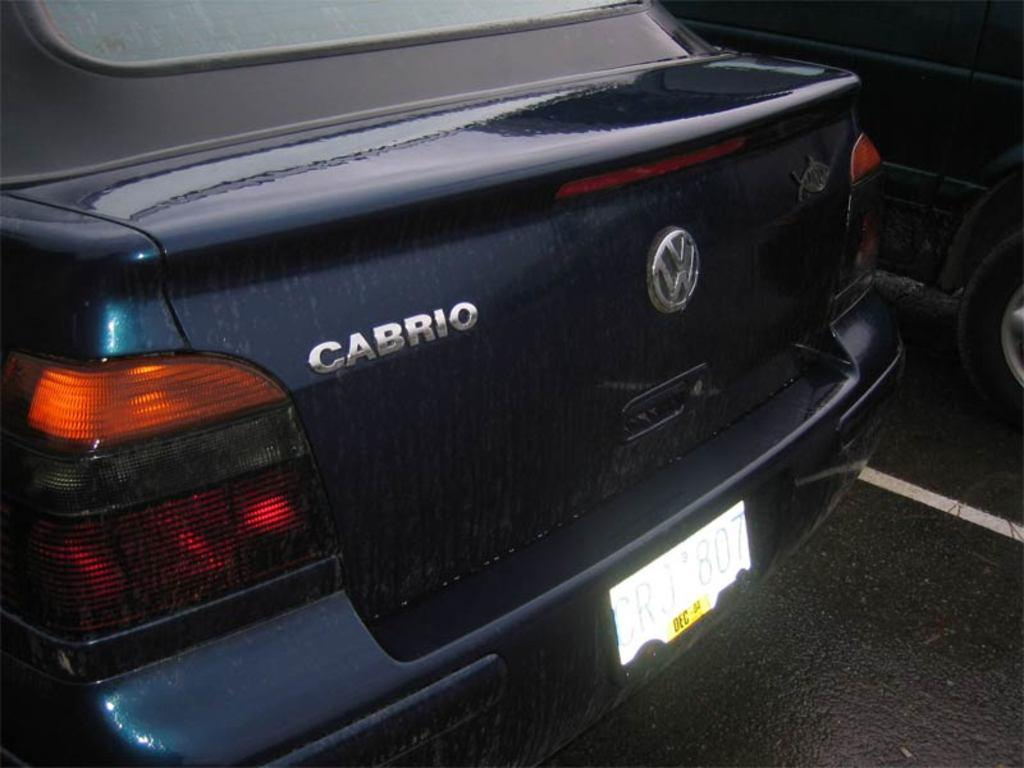What type of vehicles can be seen on the road in the image? There are cars on the road in the image. Can you describe the setting in which the cars are located? The setting is a road, which suggests that the cars are in motion or parked along the roadside. How many tails can be seen on the cars in the image? There are no tails visible on the cars in the image, as cars do not have tails. Are there any boys visible in the image? The provided facts do not mention any boys or people in the image, so we cannot determine if any are present. 